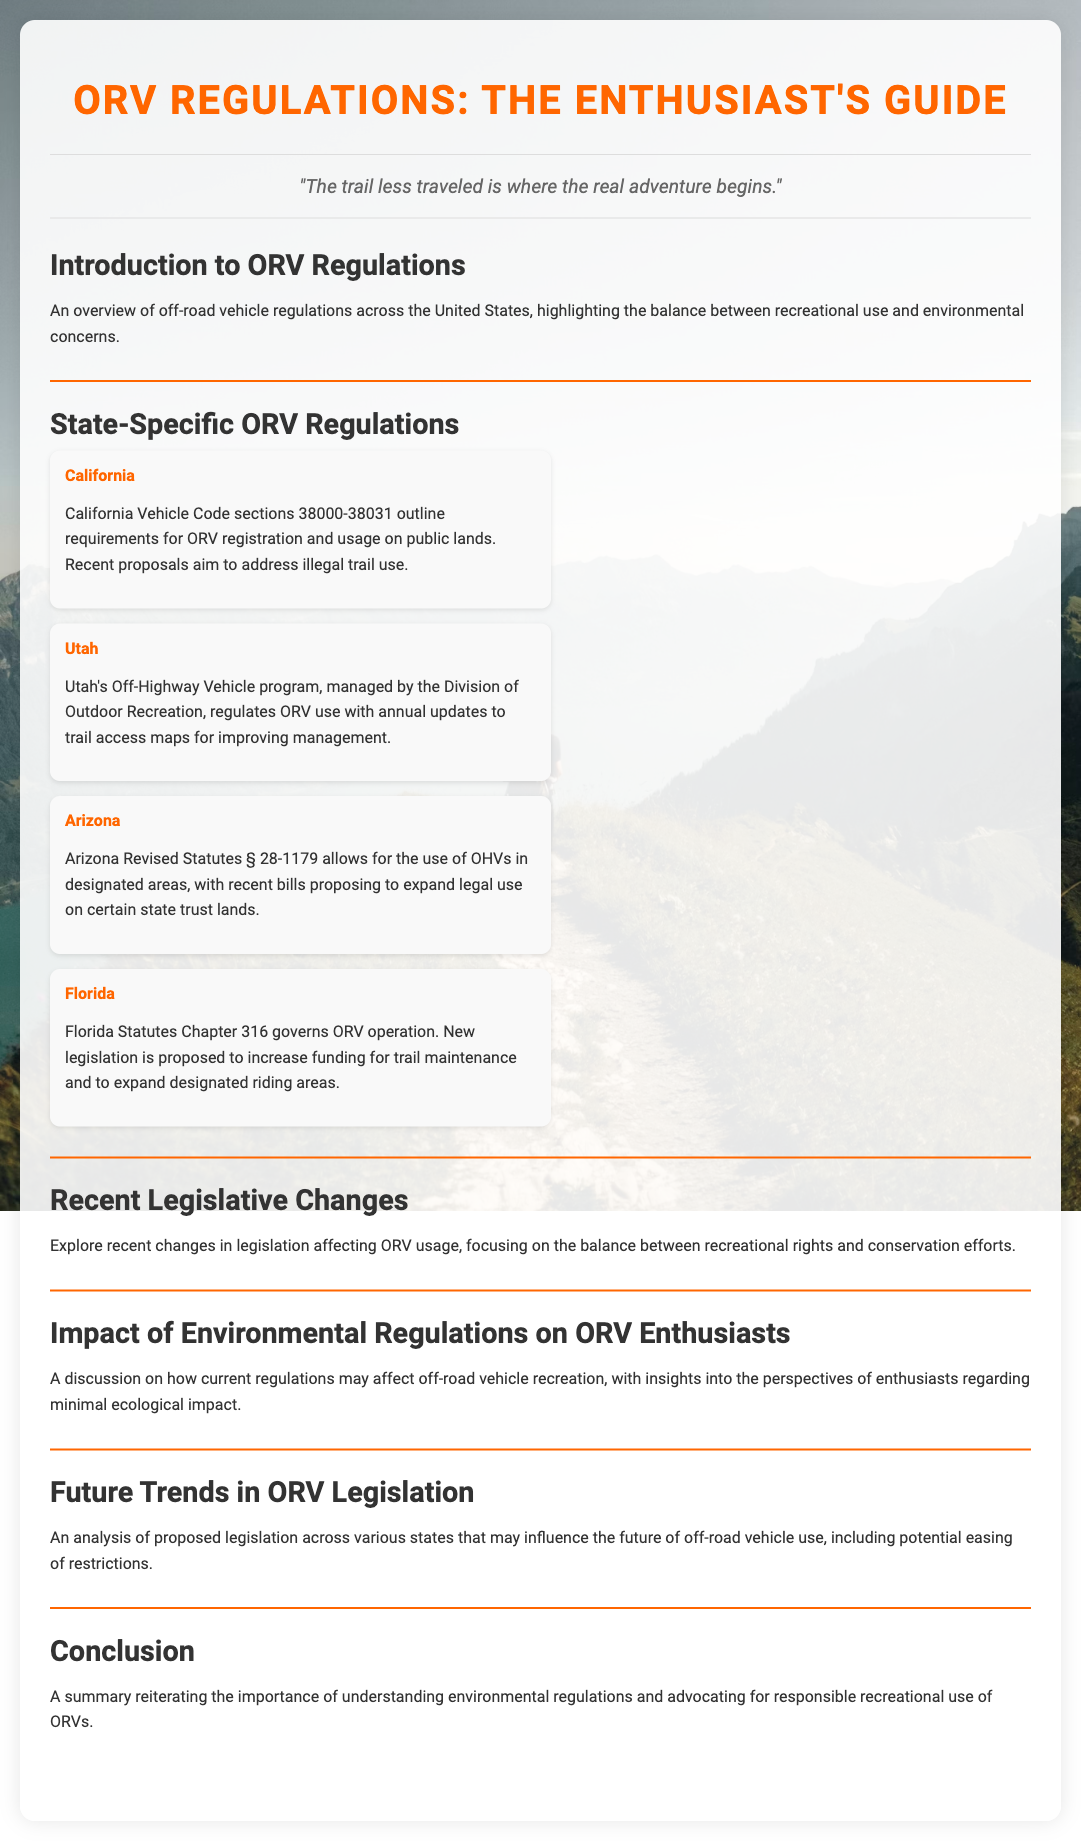What are the California Vehicle Code sections for ORV usage? The document states that California Vehicle Code sections outline requirements for ORV registration and usage on public lands.
Answer: sections 38000-38031 Which state has proposed to expand legal use of OHVs? The document mentions that Arizona has recent bills proposing to expand legal use on certain state trust lands.
Answer: Arizona What chapter governs ORV operation in Florida? The document indicates that Florida Statutes Chapter 316 governs ORV operation.
Answer: Chapter 316 What is the focus of recent legislative changes discussed? The overview mentions that it revolves around the balance between recreational rights and conservation efforts.
Answer: Recreational rights and conservation efforts What type of legislation is being analyzed for future trends? The document discusses proposed legislation that may influence the future of off-road vehicle use, specifically regarding potential easing of restrictions.
Answer: Proposed legislation How does the document characterize the impact of regulations on enthusiasts? It discusses how current regulations may affect off-road vehicle recreation, emphasizing the perspectives of enthusiasts.
Answer: Minimal ecological impact What is the title of the first section in the document? The first section is titled "Introduction to ORV Regulations."
Answer: Introduction to ORV Regulations What color is used for the section headers? The section headers are colored orange.
Answer: orange 